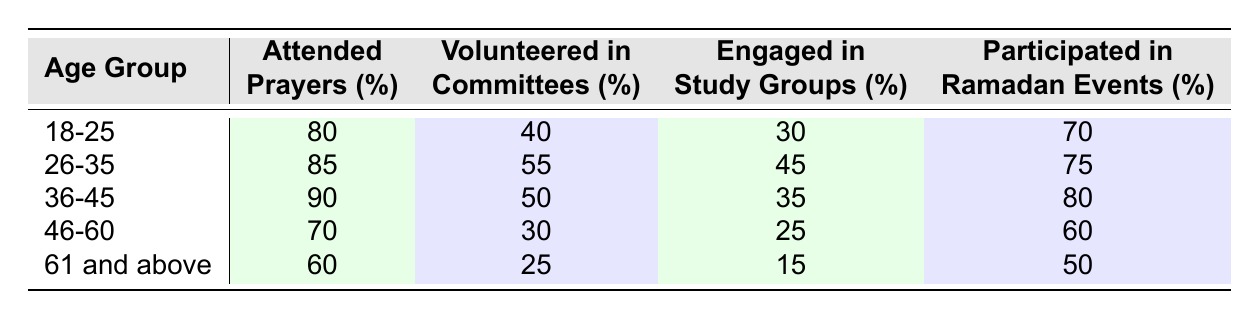What age group attended the most prayers? Looking at the "Attended Prayers (%)" column, the age group "36-45" has the highest percentage at 90%.
Answer: 36-45 Which age group had the lowest participation in Ramadan events? In the "Participated in Ramadan Events (%)" column, the age group "61 and above" shows the lowest percentage at 50%.
Answer: 61 and above What is the difference in the percentage of those who volunteered in committees between the age groups 18-25 and 46-60? The volunteering percentage for 18-25 is 40% and for 46-60 is 30%. The difference is 40% - 30% = 10%.
Answer: 10% How many age groups have over 70% participation in attending prayers? Reviewing the "Attended Prayers (%)" column, the age groups "18-25", "26-35", and "36-45" all exceed 70%, totaling 3 age groups.
Answer: 3 Is it true that age group 26-35 has a higher percentage of volunteering in committees than age group 46-60? The percentage of volunteering in committees for 26-35 is 55% and for 46-60 is 30%. Since 55% is greater than 30%, the statement is true.
Answer: Yes What is the average percentage of engaging in study groups across all age groups? To find the average, add up the percentages: (30 + 45 + 35 + 25 + 15) = 150. Divide it by the number of age groups, which is 5: 150/5 = 30%.
Answer: 30% Which age group has the highest percentage of engaged individuals in study groups? In the "Engaged in Study Groups (%)" column, the age group "26-35" has the highest percentage at 45%.
Answer: 26-35 Which activity sees the least participation among the age group 61 and above? Reviewing the data for "61 and above", the least participation is in "Engaged in Study Groups" at 15%.
Answer: Engaged in Study Groups What is the total percentage of attendance in prayers for the age groups 18-25 and 36-45? The attendance percentages for these age groups are 80% and 90%, respectively. The total is 80% + 90% = 170%.
Answer: 170% 